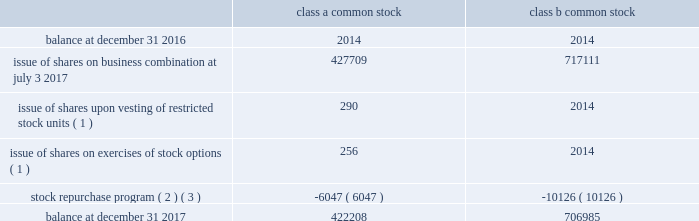Baker hughes , a ge company notes to consolidated and combined financial statements bhge 2017 form 10-k | 85 the total intrinsic value of rsus ( defined as the value of the shares awarded at the current market price ) vested and outstanding in 2017 was $ 17 million and $ 38 million , respectively .
The total fair value of rsus vested in 2017 was $ 19 million .
As of december 31 , 2017 , there was $ 98 million of total unrecognized compensation cost related to unvested rsus , which is expected to be recognized over a weighted average period of 2.5 years .
Note 12 .
Equity common stock we are authorized to issue 2 billion shares of class a common stock , 1.25 billion shares of class b common stock and 50 million shares of preferred stock each of which have a par value of $ 0.0001 per share .
On july 3 , 2017 , each share of baker hughes common stock was converted into one share of class a common stock in the company .
The number of class a common stock and class b common stock shares outstanding at december 31 , 2017 is 422 million and 707 million , respectively .
We have not issued any preferred stock .
Ge owns all the issued and outstanding class b common stock .
Each share of class a and class b common stock and the associated membership interest in bhge llc form a paired interest .
While each share of class b common stock has equal voting rights to a share of class a common stock , it has no economic rights , meaning holders of class b common stock have no right to dividends and any assets in the event of liquidation of the company .
Former baker hughes stockholders immediately after the completion of the transactions received a special one-time cash dividend of $ 17.50 per share paid by the company to holders of record of the company's class a common stock .
In addition , during 2017 the company declared and paid regular dividends of $ 0.17 per share and $ 0.18 per share to holders of record of the company's class a common stock during the quarters ended september 30 , 2017 and december 31 , 2017 , respectively .
The table presents the changes in number of shares outstanding ( in thousands ) : class a common class b common .
( 1 ) share amounts reflected above are net of shares withheld to satisfy the employee's tax withholding obligation .
( 2 ) on november 2 , 2017 , our board of directors authorized bhge llc to repurchase up to $ 3 billion of its common units from the company and ge .
The proceeds of this repurchase are to be used by bhge to repurchase class a common stock of the company on the open market , which if fully implemented would result in the repurchase of approximately $ 1.1 billion of class a common stock .
The class b common stock of the company , that is paired with repurchased common units , was repurchased by the company at par value .
The $ 3 billion repurchase authorization is the aggregate authorization for repurchases of class a and class b common stock together with its paired unit .
Bhge llc had authorization remaining to repurchase up to approximately $ 2.5 billion of its common units from bhge and ge at december 31 , 2017 .
( 3 ) during 2017 , we repurchased and canceled 6046735 shares of class a common stock for a total of $ 187 million .
We also repurchased and canceled 10126467 shares of class b common stock from ge which is paired together with common units of bhge llc for $ 314 million. .
What is the balance of class a common stock as a percentage of class b common stock? 
Computations: (422208 / 706985)
Answer: 0.5972. Baker hughes , a ge company notes to consolidated and combined financial statements bhge 2017 form 10-k | 85 the total intrinsic value of rsus ( defined as the value of the shares awarded at the current market price ) vested and outstanding in 2017 was $ 17 million and $ 38 million , respectively .
The total fair value of rsus vested in 2017 was $ 19 million .
As of december 31 , 2017 , there was $ 98 million of total unrecognized compensation cost related to unvested rsus , which is expected to be recognized over a weighted average period of 2.5 years .
Note 12 .
Equity common stock we are authorized to issue 2 billion shares of class a common stock , 1.25 billion shares of class b common stock and 50 million shares of preferred stock each of which have a par value of $ 0.0001 per share .
On july 3 , 2017 , each share of baker hughes common stock was converted into one share of class a common stock in the company .
The number of class a common stock and class b common stock shares outstanding at december 31 , 2017 is 422 million and 707 million , respectively .
We have not issued any preferred stock .
Ge owns all the issued and outstanding class b common stock .
Each share of class a and class b common stock and the associated membership interest in bhge llc form a paired interest .
While each share of class b common stock has equal voting rights to a share of class a common stock , it has no economic rights , meaning holders of class b common stock have no right to dividends and any assets in the event of liquidation of the company .
Former baker hughes stockholders immediately after the completion of the transactions received a special one-time cash dividend of $ 17.50 per share paid by the company to holders of record of the company's class a common stock .
In addition , during 2017 the company declared and paid regular dividends of $ 0.17 per share and $ 0.18 per share to holders of record of the company's class a common stock during the quarters ended september 30 , 2017 and december 31 , 2017 , respectively .
The table presents the changes in number of shares outstanding ( in thousands ) : class a common class b common .
( 1 ) share amounts reflected above are net of shares withheld to satisfy the employee's tax withholding obligation .
( 2 ) on november 2 , 2017 , our board of directors authorized bhge llc to repurchase up to $ 3 billion of its common units from the company and ge .
The proceeds of this repurchase are to be used by bhge to repurchase class a common stock of the company on the open market , which if fully implemented would result in the repurchase of approximately $ 1.1 billion of class a common stock .
The class b common stock of the company , that is paired with repurchased common units , was repurchased by the company at par value .
The $ 3 billion repurchase authorization is the aggregate authorization for repurchases of class a and class b common stock together with its paired unit .
Bhge llc had authorization remaining to repurchase up to approximately $ 2.5 billion of its common units from bhge and ge at december 31 , 2017 .
( 3 ) during 2017 , we repurchased and canceled 6046735 shares of class a common stock for a total of $ 187 million .
We also repurchased and canceled 10126467 shares of class b common stock from ge which is paired together with common units of bhge llc for $ 314 million. .
What portion of the authorized shares of class b common stock is outstanding as of december 31 , 2017? 
Computations: (707 / (1.25 * 1000))
Answer: 0.5656. Baker hughes , a ge company notes to consolidated and combined financial statements bhge 2017 form 10-k | 85 the total intrinsic value of rsus ( defined as the value of the shares awarded at the current market price ) vested and outstanding in 2017 was $ 17 million and $ 38 million , respectively .
The total fair value of rsus vested in 2017 was $ 19 million .
As of december 31 , 2017 , there was $ 98 million of total unrecognized compensation cost related to unvested rsus , which is expected to be recognized over a weighted average period of 2.5 years .
Note 12 .
Equity common stock we are authorized to issue 2 billion shares of class a common stock , 1.25 billion shares of class b common stock and 50 million shares of preferred stock each of which have a par value of $ 0.0001 per share .
On july 3 , 2017 , each share of baker hughes common stock was converted into one share of class a common stock in the company .
The number of class a common stock and class b common stock shares outstanding at december 31 , 2017 is 422 million and 707 million , respectively .
We have not issued any preferred stock .
Ge owns all the issued and outstanding class b common stock .
Each share of class a and class b common stock and the associated membership interest in bhge llc form a paired interest .
While each share of class b common stock has equal voting rights to a share of class a common stock , it has no economic rights , meaning holders of class b common stock have no right to dividends and any assets in the event of liquidation of the company .
Former baker hughes stockholders immediately after the completion of the transactions received a special one-time cash dividend of $ 17.50 per share paid by the company to holders of record of the company's class a common stock .
In addition , during 2017 the company declared and paid regular dividends of $ 0.17 per share and $ 0.18 per share to holders of record of the company's class a common stock during the quarters ended september 30 , 2017 and december 31 , 2017 , respectively .
The table presents the changes in number of shares outstanding ( in thousands ) : class a common class b common .
( 1 ) share amounts reflected above are net of shares withheld to satisfy the employee's tax withholding obligation .
( 2 ) on november 2 , 2017 , our board of directors authorized bhge llc to repurchase up to $ 3 billion of its common units from the company and ge .
The proceeds of this repurchase are to be used by bhge to repurchase class a common stock of the company on the open market , which if fully implemented would result in the repurchase of approximately $ 1.1 billion of class a common stock .
The class b common stock of the company , that is paired with repurchased common units , was repurchased by the company at par value .
The $ 3 billion repurchase authorization is the aggregate authorization for repurchases of class a and class b common stock together with its paired unit .
Bhge llc had authorization remaining to repurchase up to approximately $ 2.5 billion of its common units from bhge and ge at december 31 , 2017 .
( 3 ) during 2017 , we repurchased and canceled 6046735 shares of class a common stock for a total of $ 187 million .
We also repurchased and canceled 10126467 shares of class b common stock from ge which is paired together with common units of bhge llc for $ 314 million. .
What portion of the authorized shares of class a common stock is outstanding as of december 31 , 2017? 
Computations: (422 / (2 * 1000))
Answer: 0.211. 